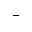Convert formula to latex. <formula><loc_0><loc_0><loc_500><loc_500>^ { - }</formula> 